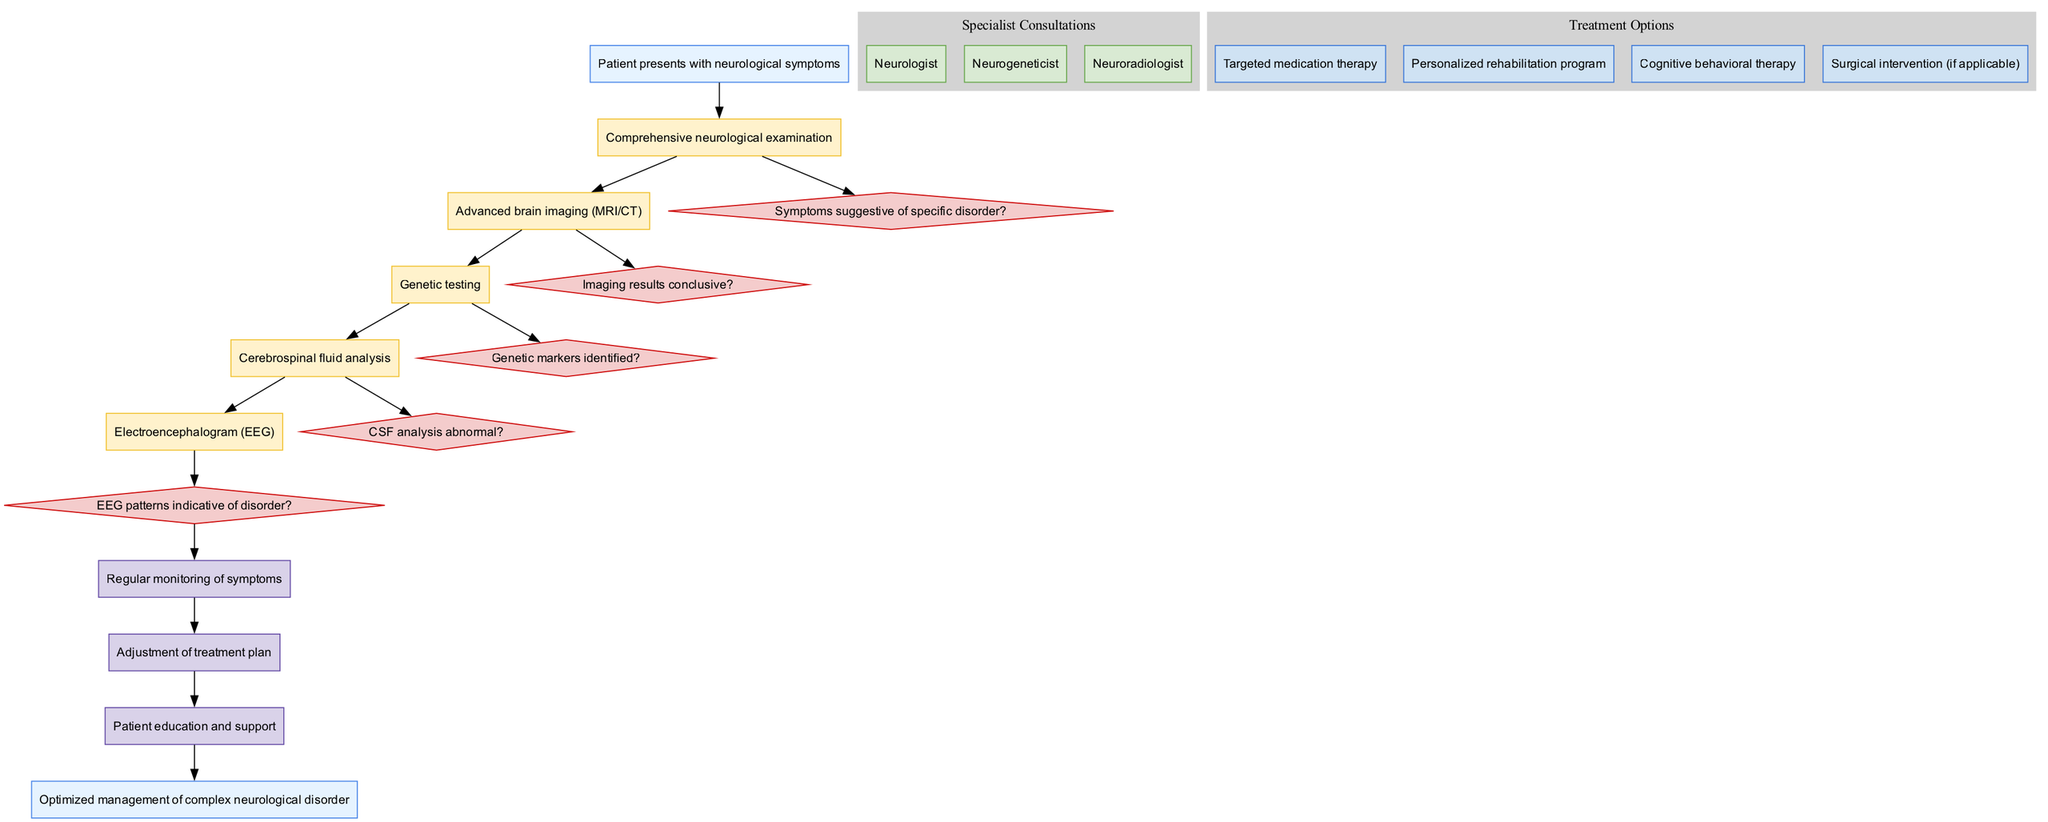What is the starting point of the pathway? The diagram shows that the pathway begins when a patient presents with neurological symptoms. This is clearly stated at the start of the diagram.
Answer: Patient presents with neurological symptoms How many diagnostic steps are there? The diagram lists a total of five diagnostic steps. By counting the nodes labeled as diagnostic steps, we find that there are five.
Answer: 5 What type of node is used to represent treatment options? The treatment options are represented using nodes that are filled with a light blue color and are rectangular in shape according to the node styles defined.
Answer: Rectangle What is the first diagnostic step in the clinical pathway? The clinical pathway indicates that the first diagnostic step is a comprehensive neurological examination, which is the first node following the start node.
Answer: Comprehensive neurological examination Which specialist consultation is listed last in the diagram? By reviewing the section for specialist consultations, we see that the last listed specialist is the neuroradiologist, positioned last in the cluster of specialists.
Answer: Neuroradiologist What follows after cerebrospinal fluid analysis in the diagnostic steps? Following cerebrospinal fluid analysis, the next step is the electroencephalogram (EEG). This can be determined by examining the order of the diagnostic steps in the diagram.
Answer: Electroencephalogram (EEG) Which decision point comes after genetic testing? The decision point that follows genetic testing is "Genetic markers identified?" This is indicated by the directed edge in the diagram leading to the corresponding decision node.
Answer: Genetic markers identified? How many treatment options are available in the pathway? The diagram identifies four treatment options. This is determined by counting the distinct nodes in the treatment options cluster.
Answer: 4 What is the endpoint of the clinical pathway? The final node in the diagram, following the follow-up steps, is the endpoint, which states the purpose of the pathway. This documentally summarizes the desired outcome of the process.
Answer: Optimized management of complex neurological disorder 